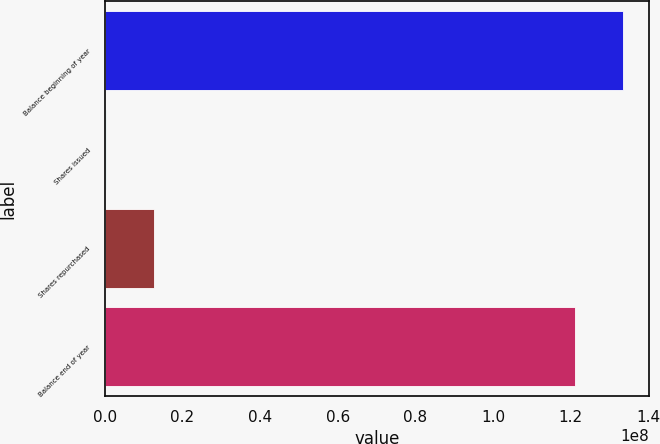<chart> <loc_0><loc_0><loc_500><loc_500><bar_chart><fcel>Balance beginning of year<fcel>Shares issued<fcel>Shares repurchased<fcel>Balance end of year<nl><fcel>1.33496e+08<fcel>281654<fcel>1.25843e+07<fcel>1.21194e+08<nl></chart> 